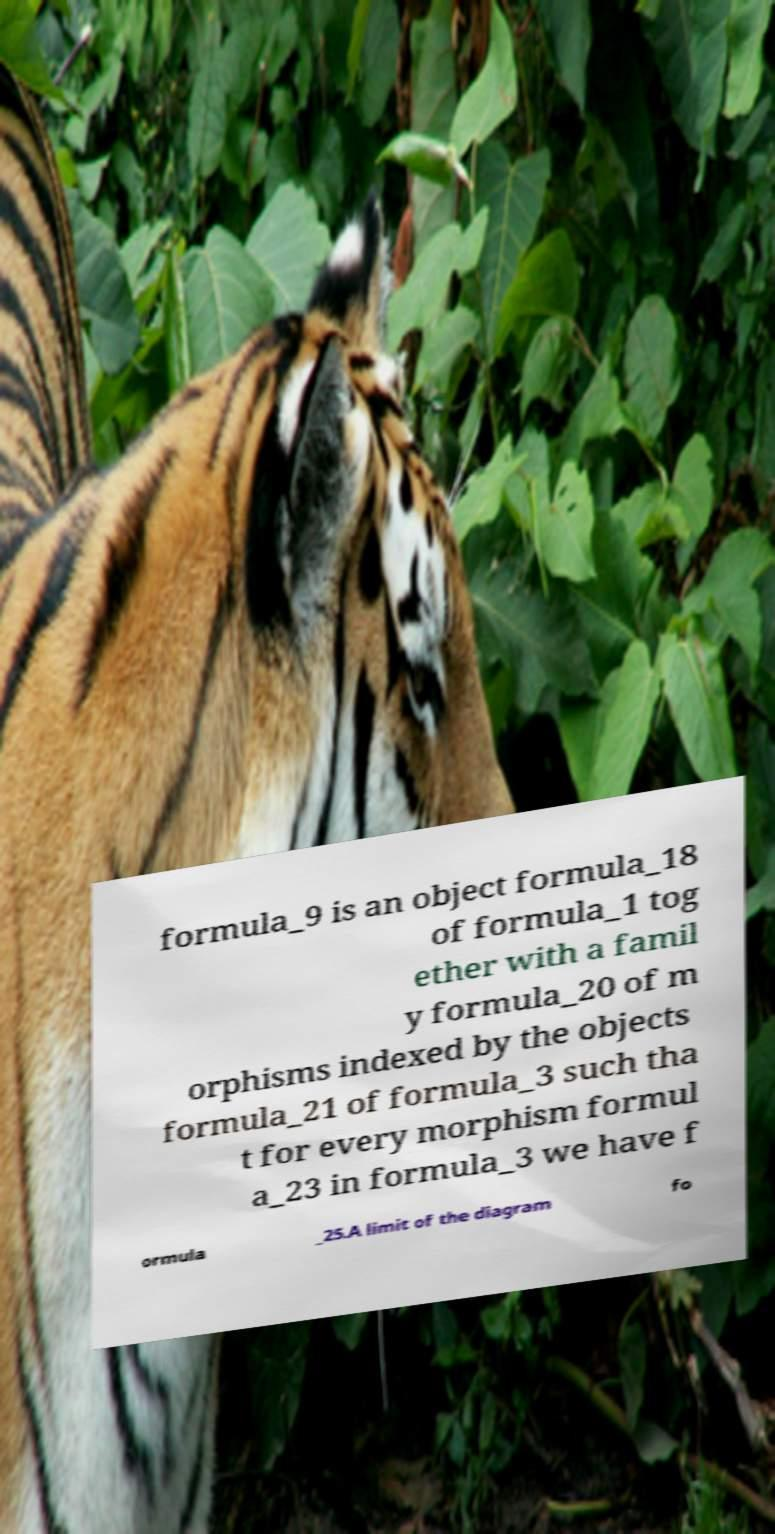Can you read and provide the text displayed in the image?This photo seems to have some interesting text. Can you extract and type it out for me? formula_9 is an object formula_18 of formula_1 tog ether with a famil y formula_20 of m orphisms indexed by the objects formula_21 of formula_3 such tha t for every morphism formul a_23 in formula_3 we have f ormula _25.A limit of the diagram fo 